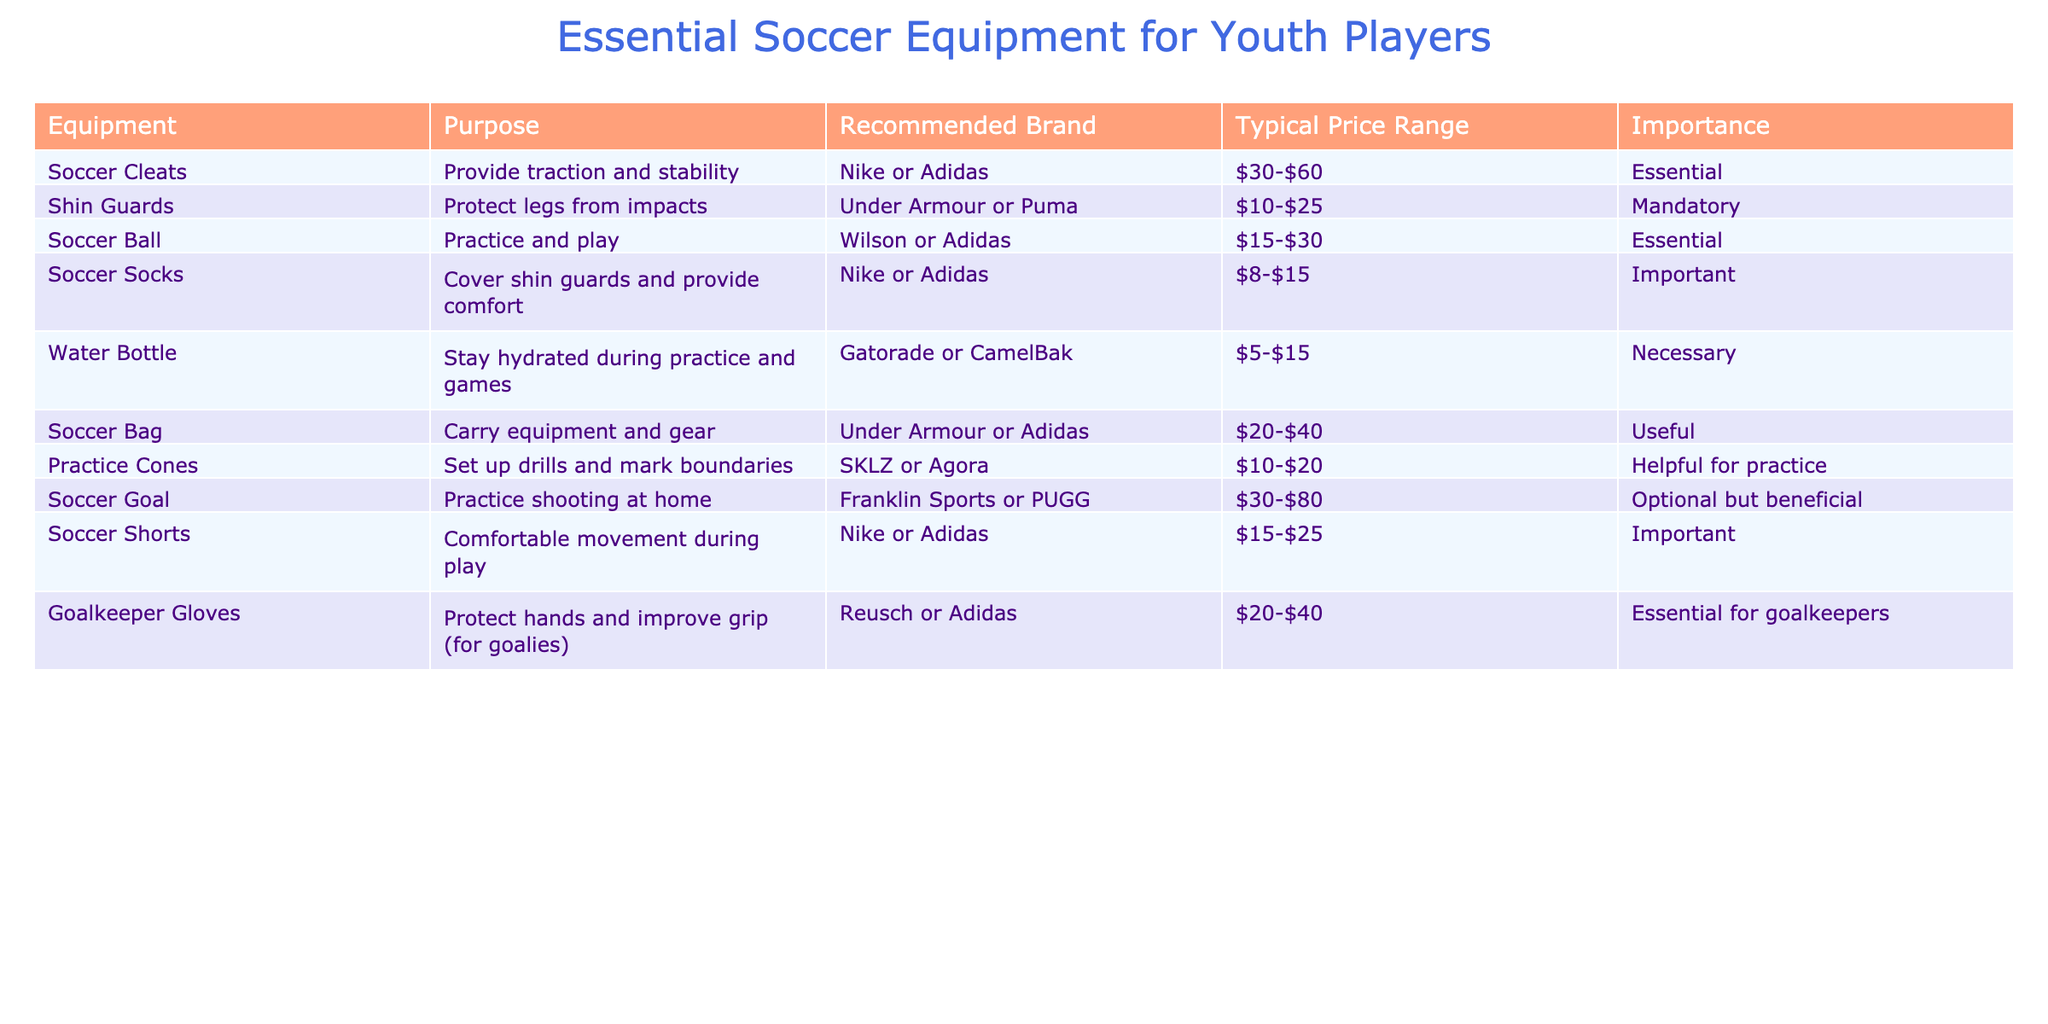What is the typical price range for soccer cleats? The table lists the typical price range for soccer cleats as $30-$60.
Answer: $30-$60 Are soccer shorts considered essential equipment? The table categorizes soccer shorts as "Important," not essential, indicating that while they are needed for comfort, they are not mandatory like cleats or shin guards.
Answer: No Which equipment has a mandatory importance level? According to the table, shin guards are categorized as mandatory.
Answer: Shin guards What is the total price range of the most expensive item listed in the table? The soccer goal has the highest price range, which is $30-$80. For the highest figure from this range, it is $80.
Answer: $80 How many pieces of equipment are considered essential? The table shows that there are four items classified as essential: soccer cleats, soccer ball, goalkeeper gloves, and water bottle. Counting these gives us four essential items.
Answer: 4 Do all recommended brands for gear fall under Nike or Adidas? No, while many items suggest Nike or Adidas, shin guards are associated with Under Armour or Puma, indicating not all brands are Nike or Adidas.
Answer: No What would be the average price range for the soccer socks and the practice cones? The typical price range for soccer socks is $8-$15, and for practice cones, it is $10-$20. Taking the midpoint of both, we have ($8 + $15)/2 = $11.5 and ($10 + $20)/2 = $15. Thus, the average of the midpoints is ($11.5 + $15)/2 = $13.25.
Answer: $13.25 Which equipment provides the purpose of protecting legs from impacts? The table specifies that shin guards are specifically designed to protect legs from impacts.
Answer: Shin guards What is the typical price range for a soccer bag? The table indicates that the typical price range for a soccer bag is $20-$40.
Answer: $20-$40 Is it necessary to have a soccer goal for practice? The table categorizes a soccer goal as "Optional but beneficial," implying that while useful, it is not necessary for practice.
Answer: No 